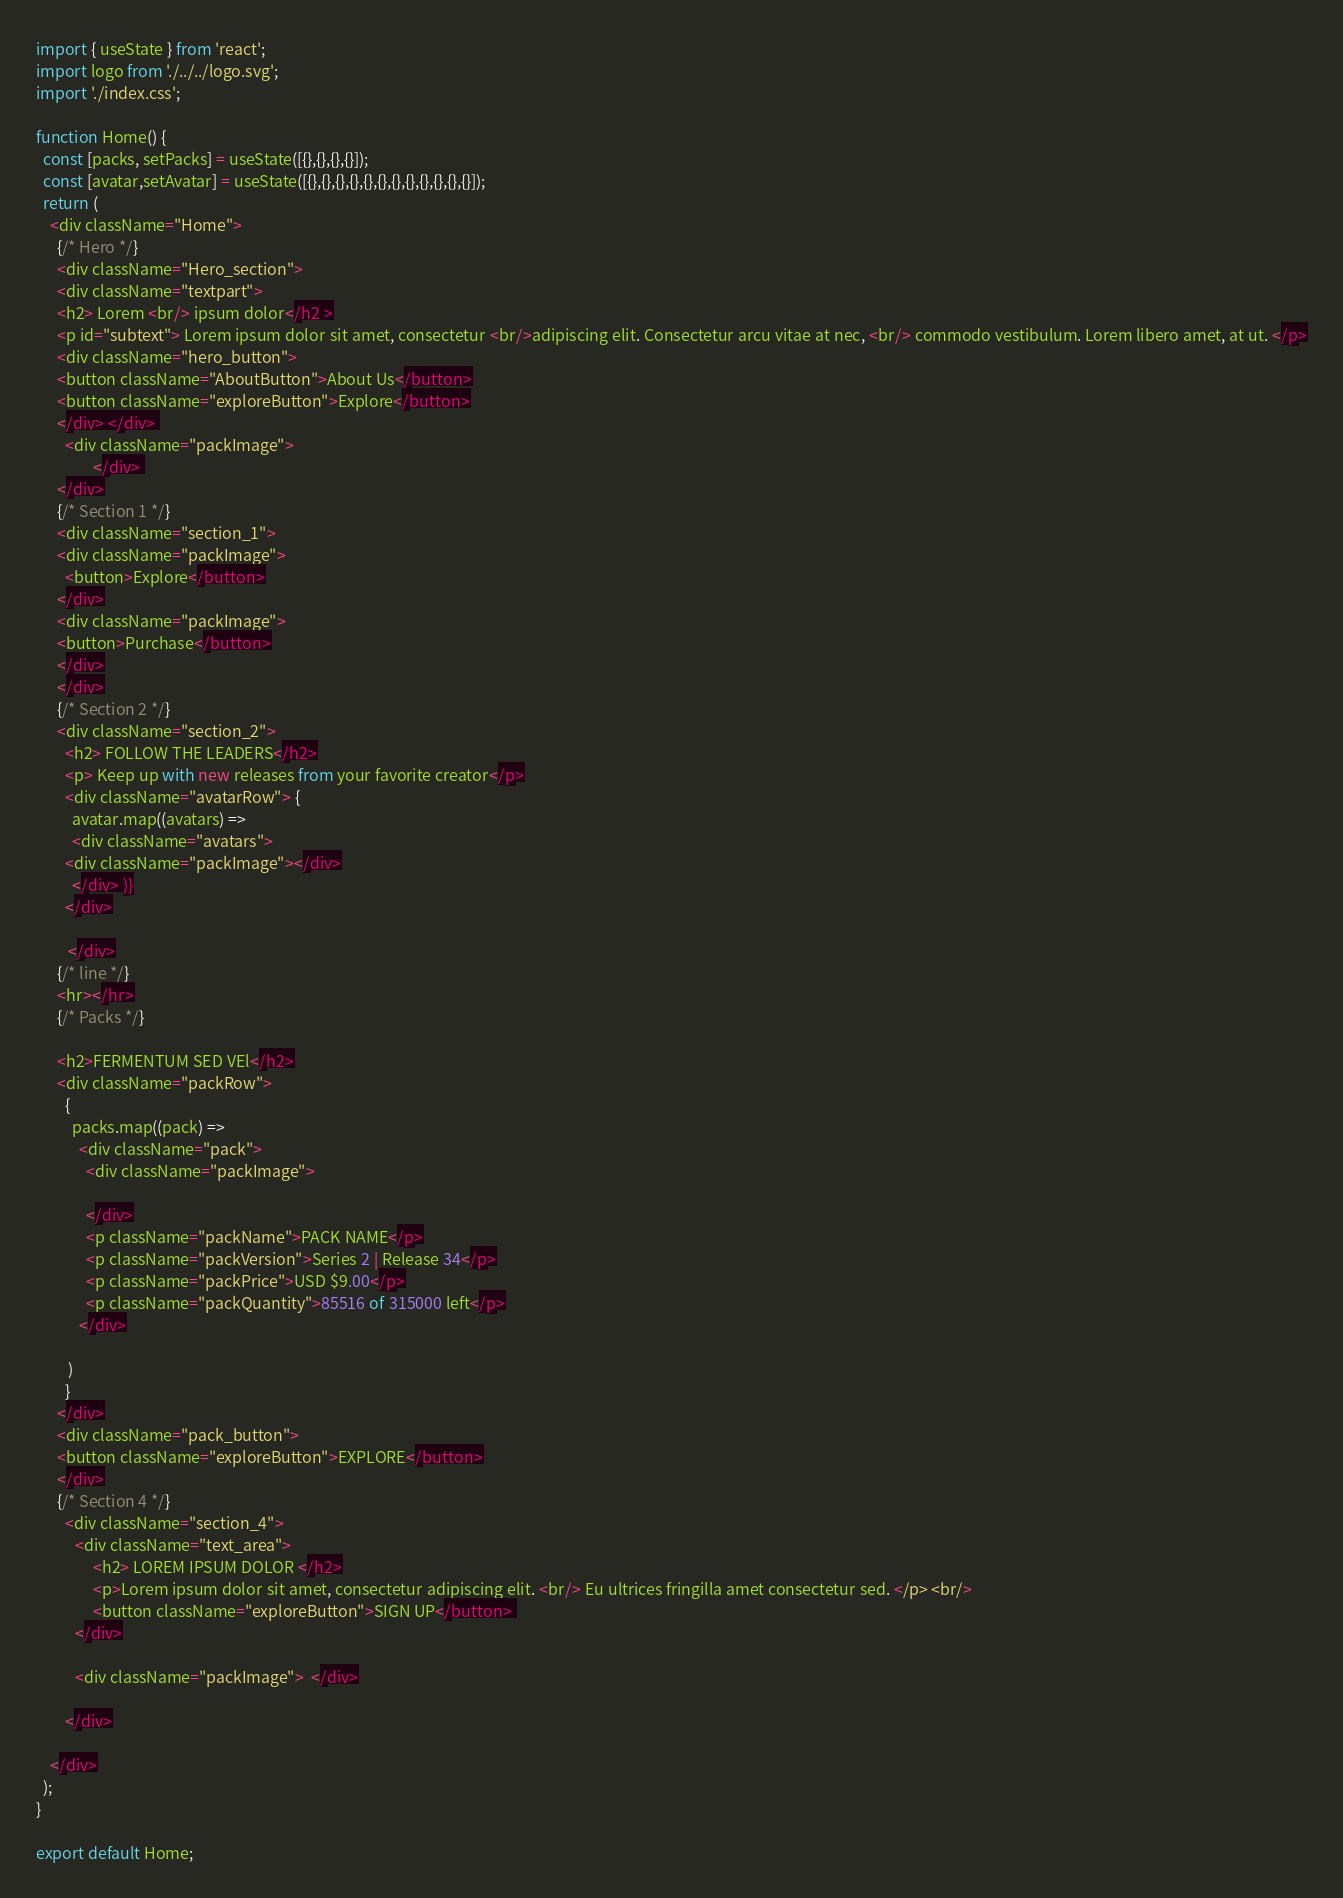<code> <loc_0><loc_0><loc_500><loc_500><_JavaScript_>import { useState } from 'react';
import logo from './../../logo.svg';
import './index.css';

function Home() {
  const [packs, setPacks] = useState([{},{},{},{}]);
  const [avatar,setAvatar] = useState([{},{},{},{},{},{},{},{},{},{},{},{}]);
  return (
    <div className="Home">
      {/* Hero */}
      <div className="Hero_section"> 
      <div className="textpart">
      <h2> Lorem <br/> ipsum dolor</h2 >
      <p id="subtext"> Lorem ipsum dolor sit amet, consectetur <br/>adipiscing elit. Consectetur arcu vitae at nec, <br/> commodo vestibulum. Lorem libero amet, at ut. </p>
      <div className="hero_button"> 
      <button className="AboutButton">About Us</button>
      <button className="exploreButton">Explore</button>
      </div> </div> 
        <div className="packImage">
                </div> 
      </div>
      {/* Section 1 */}
      <div className="section_1"> 
      <div className="packImage">
        <button>Explore</button>
      </div>
      <div className="packImage">
      <button>Purchase</button>
      </div>
      </div>
      {/* Section 2 */}
      <div className="section_2">
        <h2> FOLLOW THE LEADERS</h2>
        <p> Keep up with new releases from your favorite creator</p>
        <div className="avatarRow"> {
          avatar.map((avatars) =>
          <div className="avatars"> 
        <div className="packImage"></div>
          </div> )}
        </div>
        
         </div>
      {/* line */}
      <hr></hr>
      {/* Packs */}
    
      <h2>FERMENTUM SED VEl</h2>
      <div className="packRow">
        {
          packs.map((pack) =>
            <div className="pack">
              <div className="packImage">

              </div>
              <p className="packName">PACK NAME</p>
              <p className="packVersion">Series 2 | Release 34</p>
              <p className="packPrice">USD $9.00</p>
              <p className="packQuantity">85516 of 315000 left</p>
            </div>
         
         )
        }
      </div>
      <div className="pack_button">
      <button className="exploreButton">EXPLORE</button>
      </div>
      {/* Section 4 */}
        <div className="section_4">
           <div className="text_area">
                <h2> LOREM IPSUM DOLOR </h2>
                <p>Lorem ipsum dolor sit amet, consectetur adipiscing elit. <br/> Eu ultrices fringilla amet consectetur sed. </p> <br/>
                <button className="exploreButton">SIGN UP</button> 
           </div>

           <div className="packImage">  </div>

        </div>

    </div>
  );
}

export default Home;
</code> 